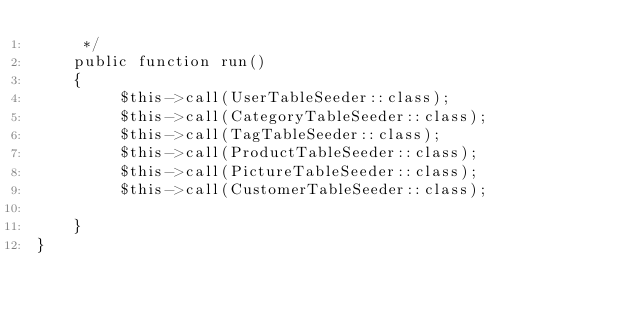<code> <loc_0><loc_0><loc_500><loc_500><_PHP_>     */
    public function run()
    {
         $this->call(UserTableSeeder::class);
         $this->call(CategoryTableSeeder::class);
         $this->call(TagTableSeeder::class);
         $this->call(ProductTableSeeder::class);
         $this->call(PictureTableSeeder::class);
         $this->call(CustomerTableSeeder::class);

    }
}
</code> 